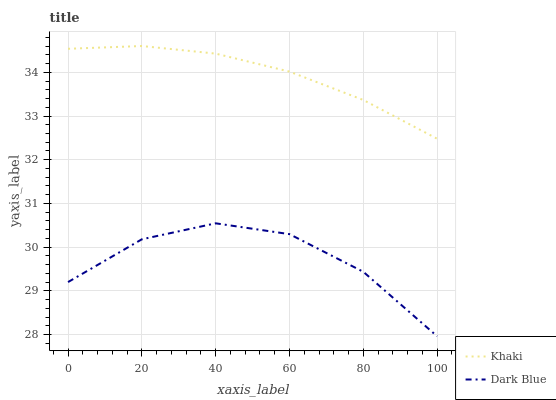Does Dark Blue have the minimum area under the curve?
Answer yes or no. Yes. Does Khaki have the maximum area under the curve?
Answer yes or no. Yes. Does Khaki have the minimum area under the curve?
Answer yes or no. No. Is Khaki the smoothest?
Answer yes or no. Yes. Is Dark Blue the roughest?
Answer yes or no. Yes. Is Khaki the roughest?
Answer yes or no. No. Does Dark Blue have the lowest value?
Answer yes or no. Yes. Does Khaki have the lowest value?
Answer yes or no. No. Does Khaki have the highest value?
Answer yes or no. Yes. Is Dark Blue less than Khaki?
Answer yes or no. Yes. Is Khaki greater than Dark Blue?
Answer yes or no. Yes. Does Dark Blue intersect Khaki?
Answer yes or no. No. 